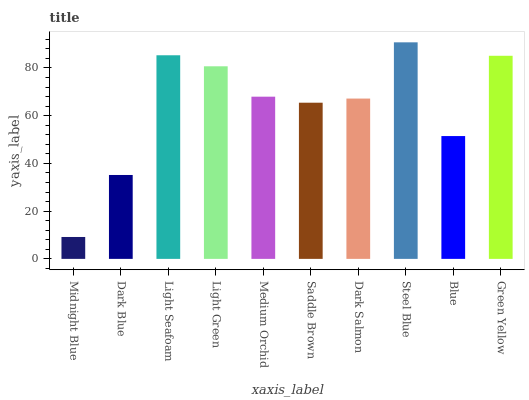Is Midnight Blue the minimum?
Answer yes or no. Yes. Is Steel Blue the maximum?
Answer yes or no. Yes. Is Dark Blue the minimum?
Answer yes or no. No. Is Dark Blue the maximum?
Answer yes or no. No. Is Dark Blue greater than Midnight Blue?
Answer yes or no. Yes. Is Midnight Blue less than Dark Blue?
Answer yes or no. Yes. Is Midnight Blue greater than Dark Blue?
Answer yes or no. No. Is Dark Blue less than Midnight Blue?
Answer yes or no. No. Is Medium Orchid the high median?
Answer yes or no. Yes. Is Dark Salmon the low median?
Answer yes or no. Yes. Is Midnight Blue the high median?
Answer yes or no. No. Is Steel Blue the low median?
Answer yes or no. No. 